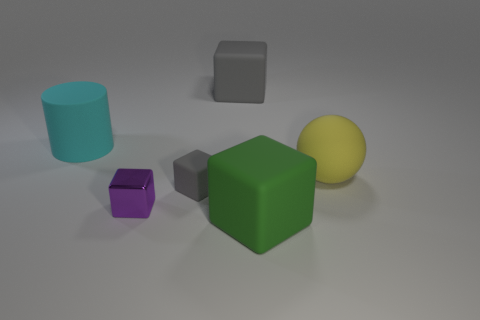Is the number of green matte things behind the big green cube greater than the number of small gray objects? no 